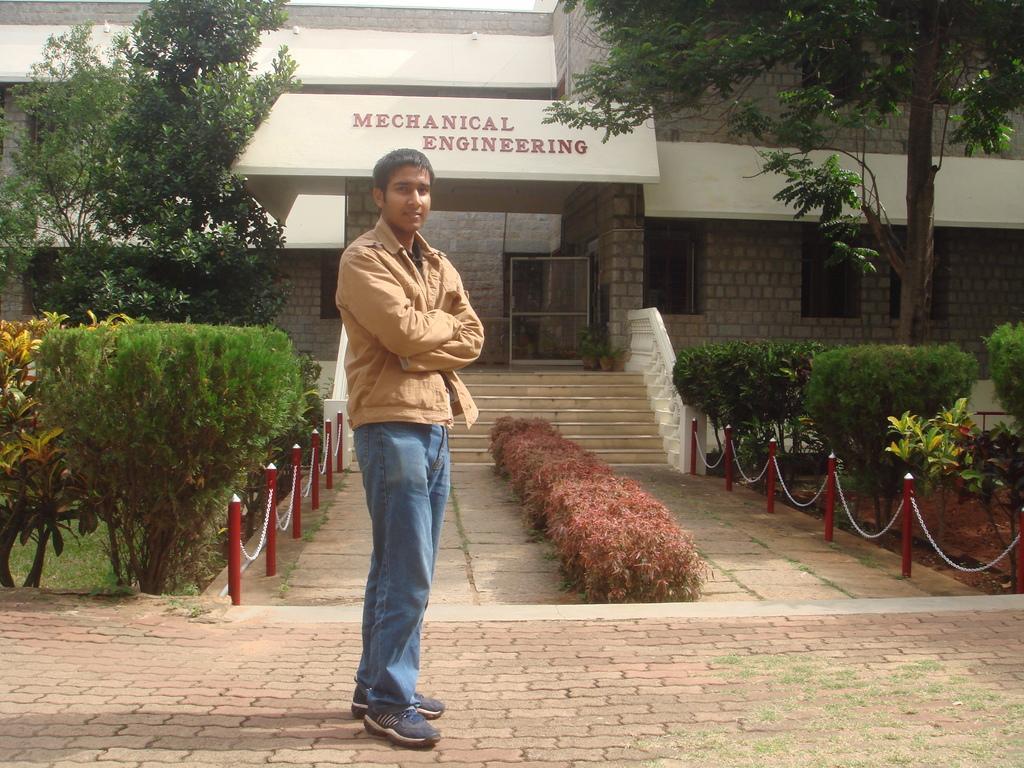In one or two sentences, can you explain what this image depicts? In this image in the center there is one man standing, and in the background there is a building, trees, plants, rods, chain, grass, sand and there is a walkway. At the bottom and in the center there are stairs and railing, and there are windows. 